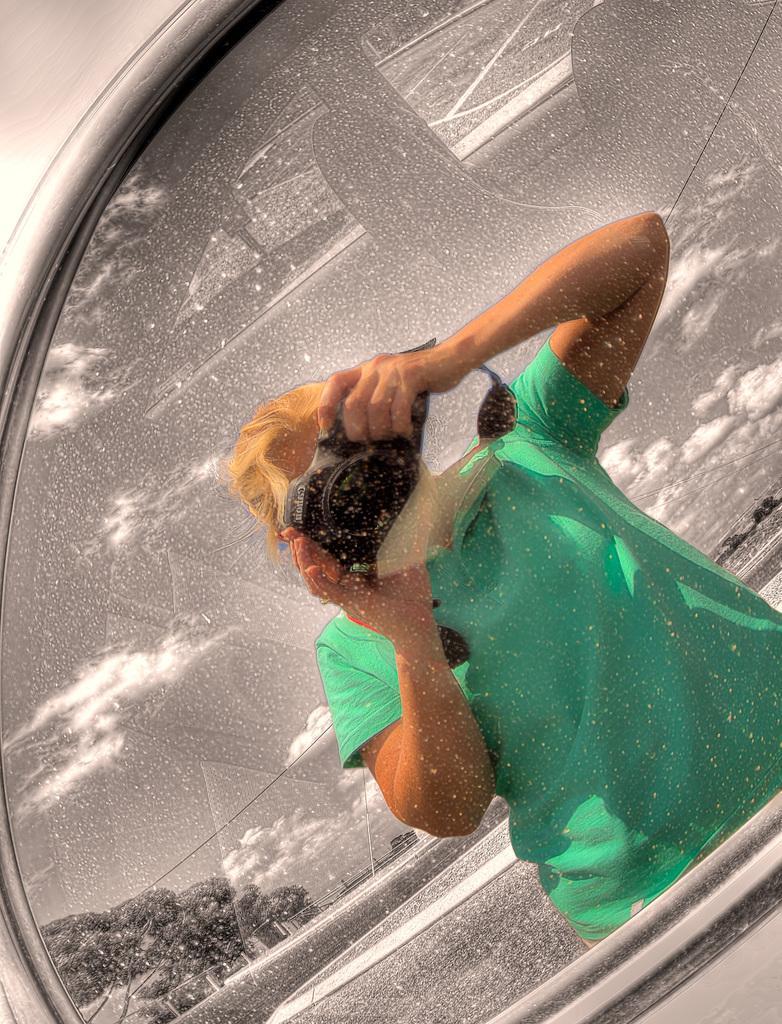In one or two sentences, can you explain what this image depicts? This is an edited image, in this picture we can see glass. There is a person holding a camera. In the background of the image we can see trees and sky with clouds. 